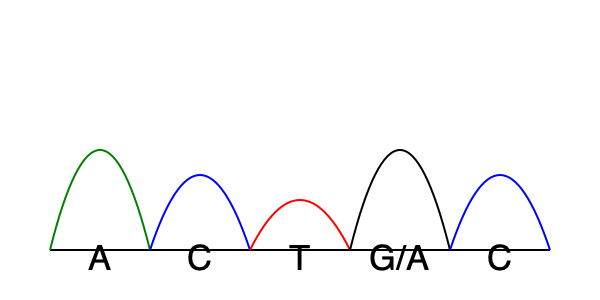Analyze the Sanger sequencing chromatogram above. At which position is there evidence of a single nucleotide polymorphism (SNP), and what are the possible nucleotides at this position? To identify a single nucleotide polymorphism (SNP) in a Sanger sequencing chromatogram, we need to look for positions where there are two overlapping peaks. This indicates the presence of two different nucleotides at the same position in the DNA sequence. Let's analyze the chromatogram step-by-step:

1. The first peak (green) represents an Adenine (A).
2. The second peak (blue) represents a Cytosine (C).
3. The third peak (red) represents a Thymine (T).
4. The fourth peak shows two overlapping signals:
   - A black peak, which typically represents Guanine (G)
   - A green peak, which represents Adenine (A)
5. The fifth peak (blue) represents another Cytosine (C).

The presence of two overlapping peaks at the fourth position indicates a SNP. This means that in the population being studied, some individuals have a G at this position, while others have an A.

Therefore, the SNP is located at the fourth position in this sequence, and the possible nucleotides at this position are G and A.
Answer: Position 4; G/A 